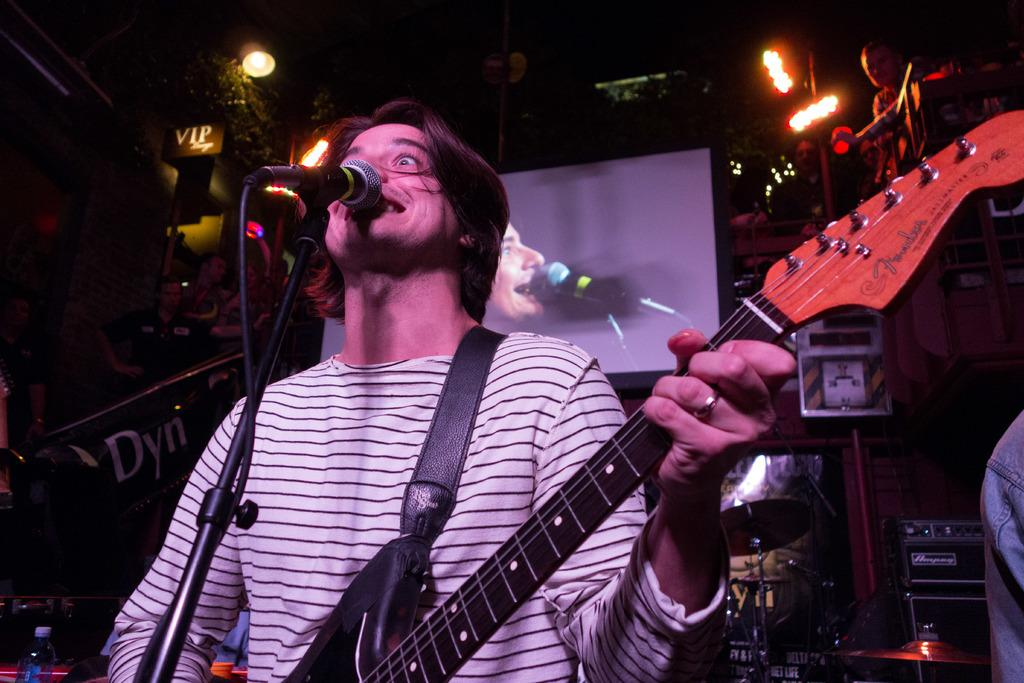What is the man in the image doing? The man is holding a guitar and singing a song. What object is the man using to amplify his voice? The man is in front of a microphone. What can be seen in the background of the image? There is a screen and a light in the background. What type of stitch is the man using to hold the guitar in the image? The man is not using a stitch to hold the guitar; he is simply holding it with his hands. How does the man's muscle strength contribute to his performance in the image? The image does not provide information about the man's muscle strength, so it cannot be determined how it contributes to his performance. 